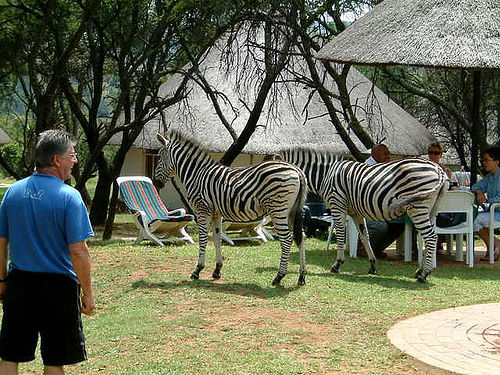What time of day does it appear to be in the image? Given the shadows cast on the ground and the quality of light, it appears to be midday or early afternoon. This is a common time for people to enjoy outdoor activities in the pleasant weather. 